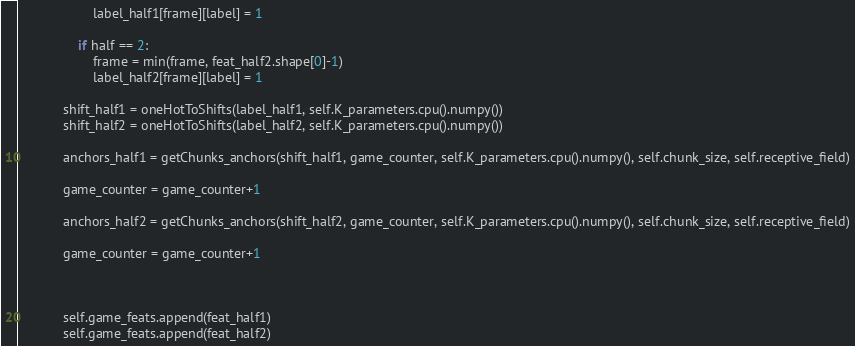<code> <loc_0><loc_0><loc_500><loc_500><_Python_>                    label_half1[frame][label] = 1

                if half == 2:
                    frame = min(frame, feat_half2.shape[0]-1)
                    label_half2[frame][label] = 1

            shift_half1 = oneHotToShifts(label_half1, self.K_parameters.cpu().numpy())
            shift_half2 = oneHotToShifts(label_half2, self.K_parameters.cpu().numpy())

            anchors_half1 = getChunks_anchors(shift_half1, game_counter, self.K_parameters.cpu().numpy(), self.chunk_size, self.receptive_field)

            game_counter = game_counter+1

            anchors_half2 = getChunks_anchors(shift_half2, game_counter, self.K_parameters.cpu().numpy(), self.chunk_size, self.receptive_field)

            game_counter = game_counter+1



            self.game_feats.append(feat_half1)
            self.game_feats.append(feat_half2)</code> 